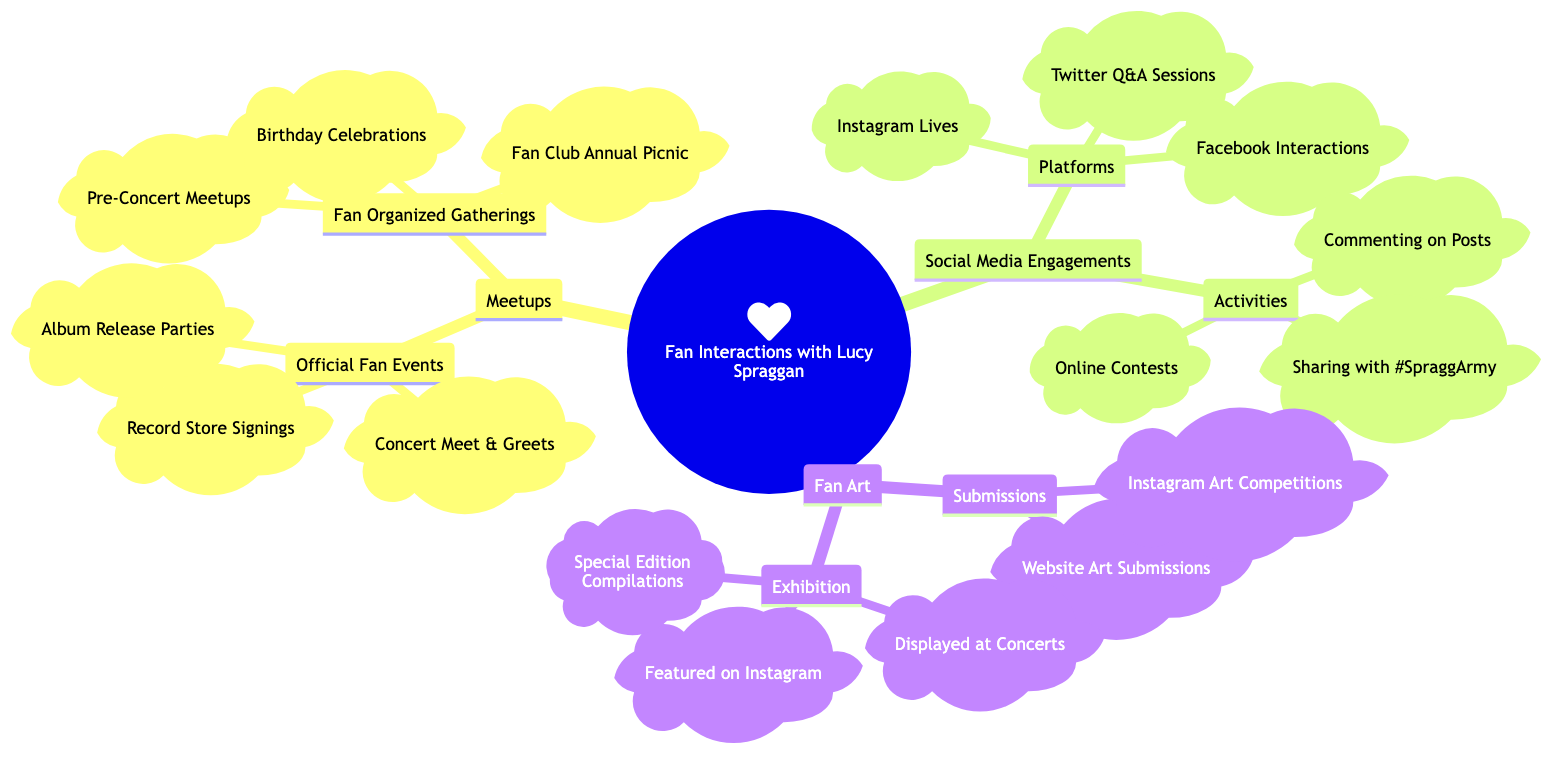What are the official fan events listed in the diagram? To answer this, we can look under the "Meetups" section and find the "Official Fan Events" node. This node lists three events: "Lucy Spraggan Concert Meet & Greets," "Record Store Signings for 'Join the Club,'" and "Special Events such as Album Release Parties."
Answer: Lucy Spraggan Concert Meet & Greets, Record Store Signings for 'Join the Club,' Special Events such as Album Release Parties How many platforms for social media engagements are mentioned? We can locate the "Social Media Engagements" section and then specifically find the "Platforms" node. This node contains three items: "Instagram Lives and Stories," "Twitter Q&A Sessions," and "Facebook Page Interactions." Therefore, the number of platforms is three.
Answer: 3 What type of fan art competition is mentioned? This question refers to the "Fan Art" section, particularly the "Submissions" node. Under this section, one of the listed items is "Fan Art Competitions on Instagram," which specifies the nature of the competition.
Answer: Fan Art Competitions on Instagram Which activities are involved in social media engagements? We can analyze the "Social Media Engagements" section, looking under the "Activities" node. There are three activities noted: "Commenting on Posts," "Sharing Fan Experiences using Hashtags like #SpraggArmy," and "Participating in Online Contests and Giveaways."
Answer: Commenting on Posts, Sharing Fan Experiences using Hashtags like #SpraggArmy, Participating in Online Contests and Giveaways How many categories are there under Meetups? To answer this, we examine the "Meetups" section of the mind map, which comprises two main categories: "Official Fan Events" and "Fan Organized Gatherings." Therefore, there are two categories.
Answer: 2 What is the purpose of the fan art submissions? Looking at the "Fan Art" section, particularly under "Submissions," we see that the purpose is twofold: to submit "Drawing and Paintings via Lucy’s Official Website" and to participate in "Fan Art Competitions on Instagram."
Answer: To submit Drawing and Paintings, participate in Fan Art Competitions How are fan art submissions exhibited according to the diagram? We start in the "Fan Art" section and go to "Exhibition." There are three ways in which these submissions are exhibited: "Featured on Lucy Spraggan's Instagram," "Displayed at Concert Venues," and "Compilation in Special Edition Albums or Booklets."
Answer: Featured on Lucy Spraggan's Instagram, Displayed at Concert Venues, Compilation in Special Edition Albums or Booklets What is a unique characteristic of the organized gatherings mentioned? We look at the "Fan Organized Gatherings" under the "Meetups" section. One unique characteristic highlighted is that these gatherings can be informal and include events like "Pre-Concert Meetups" and "Lucy Spraggan Fan Club Annual Picnic."
Answer: Informal and diverse events What type of engagement is encouraged through commenting on posts? The "Activities" node under "Social Media Engagements" indicates that commenting on posts encourages interaction between Lucy and her fans. This is an intended behavior promoted through her social media platforms.
Answer: Interaction between Lucy and her fans 